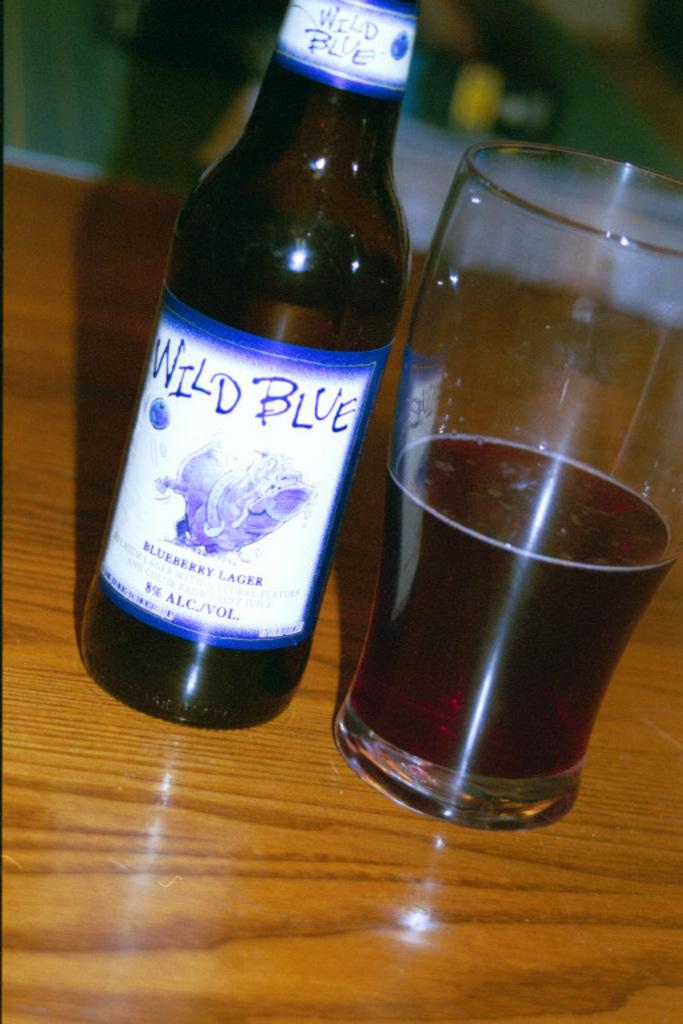What is the % alcohol?
Give a very brief answer. 8%. 